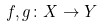<formula> <loc_0><loc_0><loc_500><loc_500>f , g \colon X \to Y</formula> 